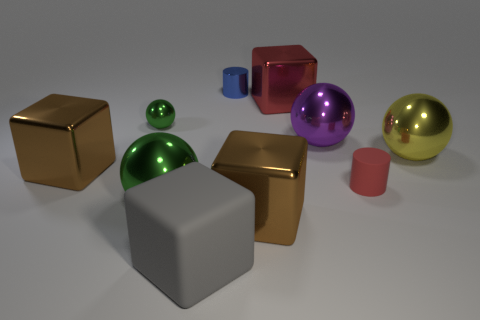Subtract all blocks. How many objects are left? 6 Subtract 0 yellow cubes. How many objects are left? 10 Subtract all small cylinders. Subtract all tiny green objects. How many objects are left? 7 Add 5 big gray objects. How many big gray objects are left? 6 Add 1 gray matte things. How many gray matte things exist? 2 